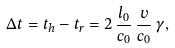Convert formula to latex. <formula><loc_0><loc_0><loc_500><loc_500>\Delta t = t _ { h } - t _ { r } = 2 \, \frac { l _ { 0 } } { c _ { 0 } } \, \frac { v } { c _ { 0 } } \, \gamma ,</formula> 